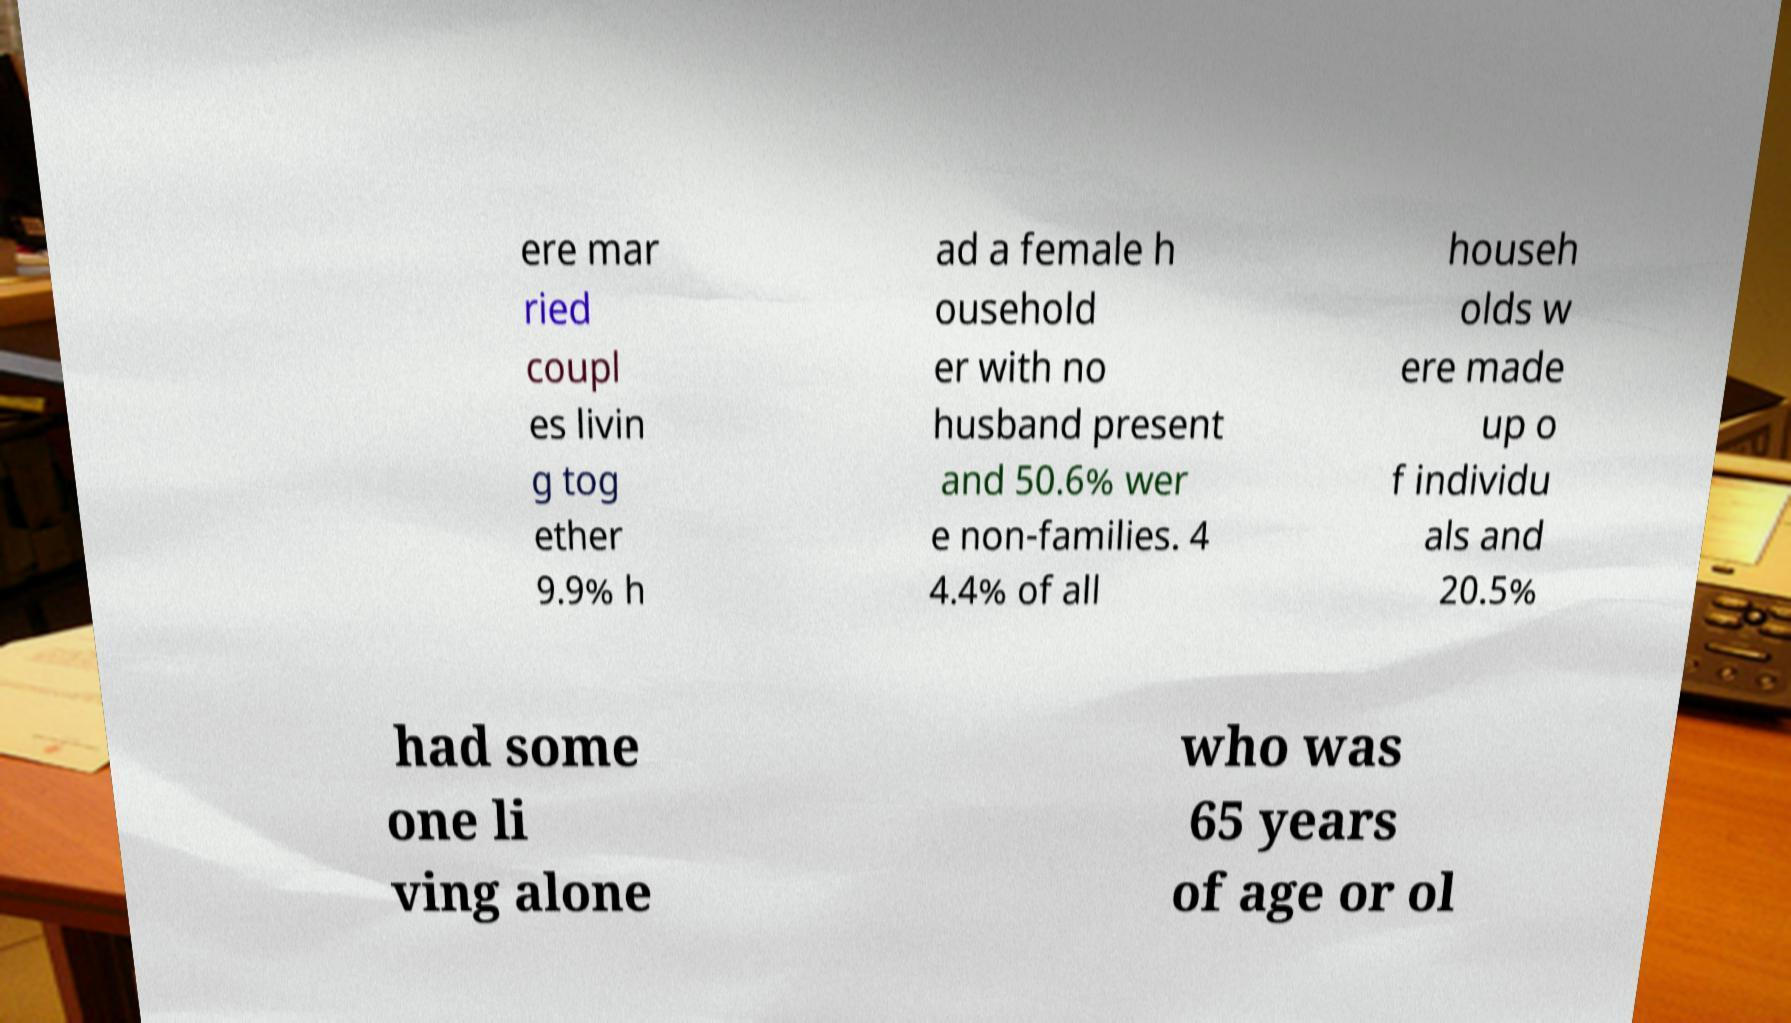For documentation purposes, I need the text within this image transcribed. Could you provide that? ere mar ried coupl es livin g tog ether 9.9% h ad a female h ousehold er with no husband present and 50.6% wer e non-families. 4 4.4% of all househ olds w ere made up o f individu als and 20.5% had some one li ving alone who was 65 years of age or ol 